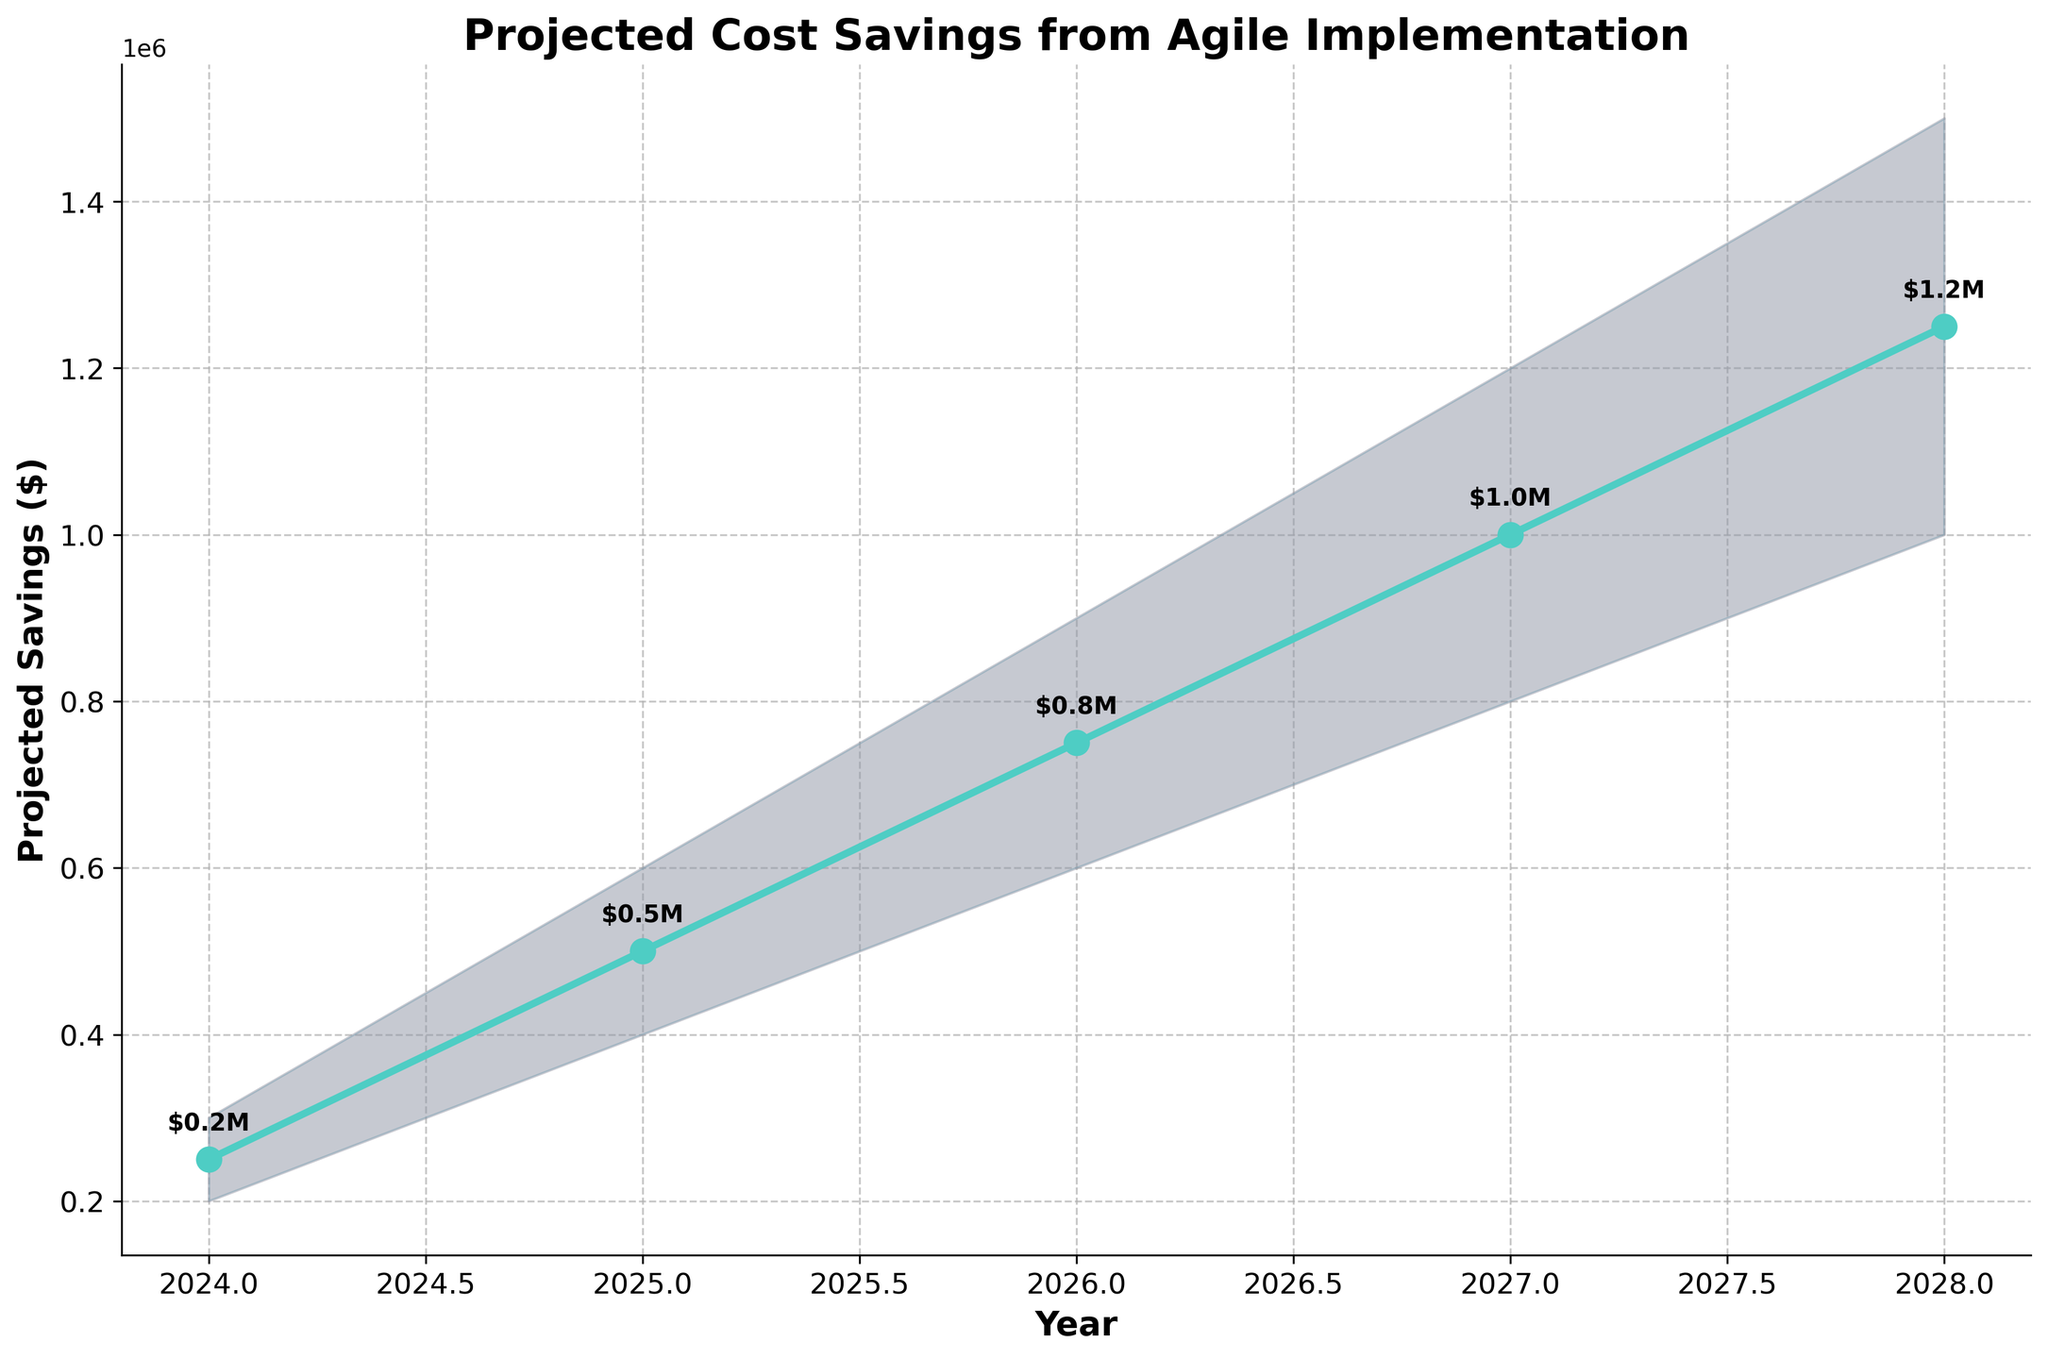What is the title of the fan chart? The title is displayed at the top of the chart and reads "Projected Cost Savings from Agile Implementation".
Answer: Projected Cost Savings from Agile Implementation How many years are projected in the fan chart? The x-axis shows each year from 2024 to 2028, so there are 5 years in total.
Answer: 5 What is the projected saving for the year 2026? The projected savings for 2026 is shown directly on the chart near the data point for 2026, which is $750,000.
Answer: $750,000 Between which years can we see the highest change in projected savings? By looking at the slope of the projected savings line, the steepest increase occurs between 2027 and 2028, going from $1,000,000 to $1,250,000.
Answer: 2027 and 2028 What is the lowest estimated saving in 2028? The lowest estimate for 2028 can be seen at the bottom of the shaded area for that year, which is $1,000,000.
Answer: $1,000,000 How does the high estimate change from 2024 to 2028? The high estimate increases over the years, starting from $300,000 in 2024 to $1,500,000 in 2028.
Answer: Increases from $300,000 to $1,500,000 What is the difference between the high and low estimates for the year 2025? For 2025, the high estimate is $600,000 and the low estimate is $400,000. The difference is calculated as $600,000 - $400,000 = $200,000.
Answer: $200,000 What is the average projected savings over the 5 years? The projected savings for each year are $250,000, $500,000, $750,000, $1,000,000, and $1,250,000. Their average is calculated as (250,000 + 500,000 + 750,000 + 1,000,000 + 1,250,000) / 5 = $750,000.
Answer: $750,000 Which year has the smallest uncertainty range between the high and low estimates? The uncertainty is the smallest for the year 2024, where the range is from $200,000 to $300,000, making the difference $100,000. This range increases in subsequent years.
Answer: 2024 What is the most significant visual feature of the fan chart? The most significant visual feature of the fan chart is the shaded areas representing the confidence intervals (low and high estimates) around the line of projected savings, showing the potential range of savings each year.
Answer: Shaded confidence intervals 